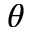<formula> <loc_0><loc_0><loc_500><loc_500>\theta</formula> 